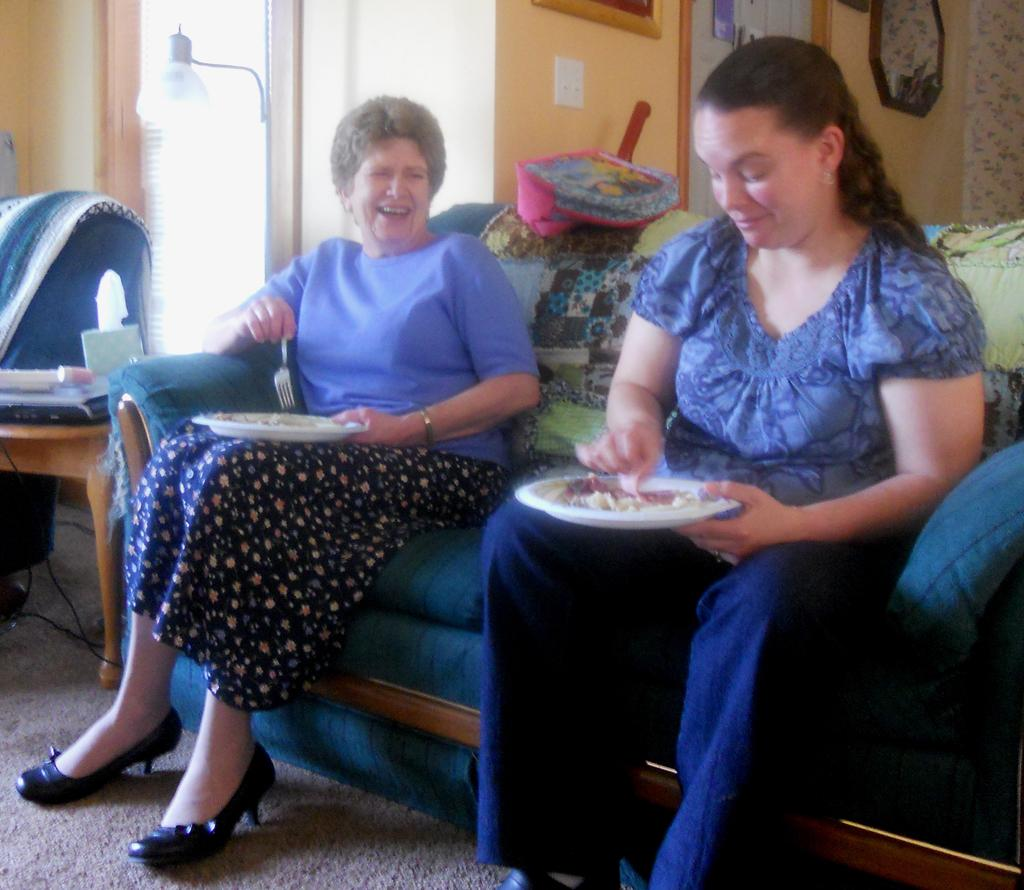How many people are in the image? There are two women in the image. What are the women doing in the image? The women are sitting on a couch and holding plates. What is on the plates that the women are holding? There is food on the plates. How are the women feeling or expressing themselves in the image? The women are laughing. What type of hair accessory can be seen on the women in the image? There is no mention of hair or hair accessories in the provided facts, so we cannot determine if any are present in the image. 